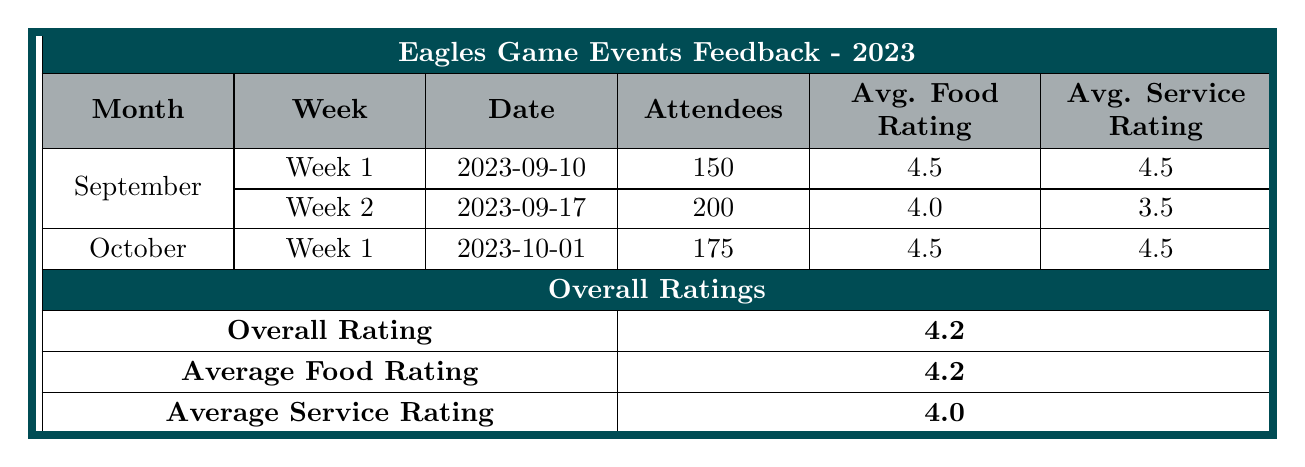What was the total number of attendees for all Eagles game events in September? In September, there were two game weeks with 150 attendees in Week 1 and 200 in Week 2. The total can be calculated as 150 + 200 = 350.
Answer: 350 What is the average food rating from all the feedback provided in October? In October, Week 1 had a food rating of 4.5. There’s only one week of feedback, so the average is simply 4.5.
Answer: 4.5 Was there any week in September where the average service rating was below 4.0? Looking at the average service ratings, Week 1 has a rating of 4.5 and Week 2 has a rating of 3.5. Since 3.5 is below 4.0, the answer is yes.
Answer: Yes What was the average overall rating based on the feedback provided in September? Adding the ratings for Week 1 (5, 4) and Week 2 (3, 5) gives us (5 + 4 + 3 + 5) = 17 ratings from 4 customers, so the average is 17 / 4 = 4.25.
Answer: 4.25 How many total feedback comments were received for the Eagles game events in September? There are two weeks of feedback in September with 2 comments from Week 1 and 2 comments from Week 2, totaling 2 + 2 = 4 comments.
Answer: 4 Which week had the highest number of attendees? Comparing the attendee counts, Week 1 had 150 and Week 2 had 200 in September. Therefore, Week 2 had the highest attendance.
Answer: Week 2 What is the average service rating for all events combined? Adding the average service ratings from all weeks gives us (4.5 for Week 1 in September + 3.5 for Week 2 + 4.5 for October) = 12.5 from 3 weeks, so the average is 12.5 / 3 = 4.17.
Answer: 4.17 Did the average food rating in October exceed the average food rating in September? The average food rating in October is 4.5, while in September, Week 1 had 4.5 and Week 2 had 4.0, so the average for September is (4.5 + 4.0) / 2 = 4.25. Since 4.5 > 4.25, the answer is yes.
Answer: Yes What is the difference in average attendees between Week 2 in September and Week 1 in October? Week 2 in September had 200 attendees and Week 1 in October had 175 attendees. The difference is 200 - 175 = 25.
Answer: 25 How many total feedback comments indicated a rating of 5? In Week 1 of September, 2 comments had ratings of 5, and in Week 2, there was 1 comment with a rating of 5, totaling 3 comments.
Answer: 3 